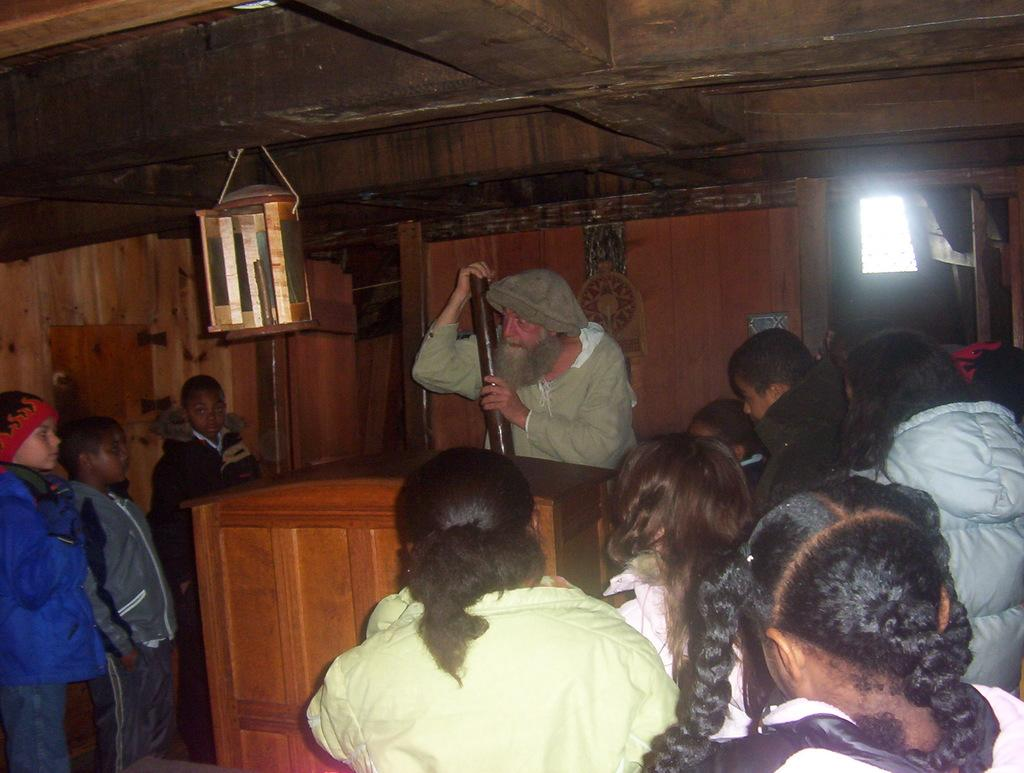Who or what can be seen in the image? There are people in the image. What is the man holding in his hand? The man is holding a wooden object in his hand. What piece of furniture is present in the image? There is a desk in the image. What can be seen in the background of the image? There are objects visible in the background of the image. What type of worm can be seen crawling on the desk in the image? There is no worm present in the image; it only features people, a man holding a wooden object, and a desk. What shape is the bit that the man is using to carve the wooden object? The image does not show the man using a bit to carve the wooden object, nor does it provide any information about the shape of a potential bit. 